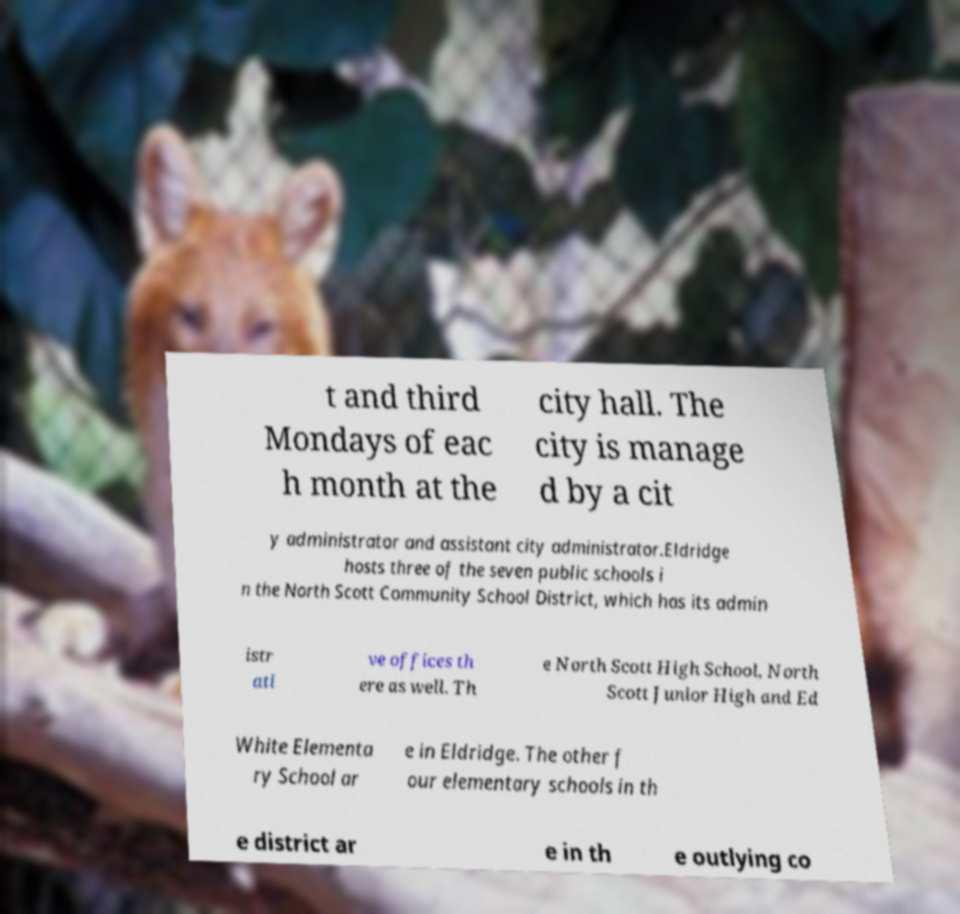What messages or text are displayed in this image? I need them in a readable, typed format. t and third Mondays of eac h month at the city hall. The city is manage d by a cit y administrator and assistant city administrator.Eldridge hosts three of the seven public schools i n the North Scott Community School District, which has its admin istr ati ve offices th ere as well. Th e North Scott High School, North Scott Junior High and Ed White Elementa ry School ar e in Eldridge. The other f our elementary schools in th e district ar e in th e outlying co 